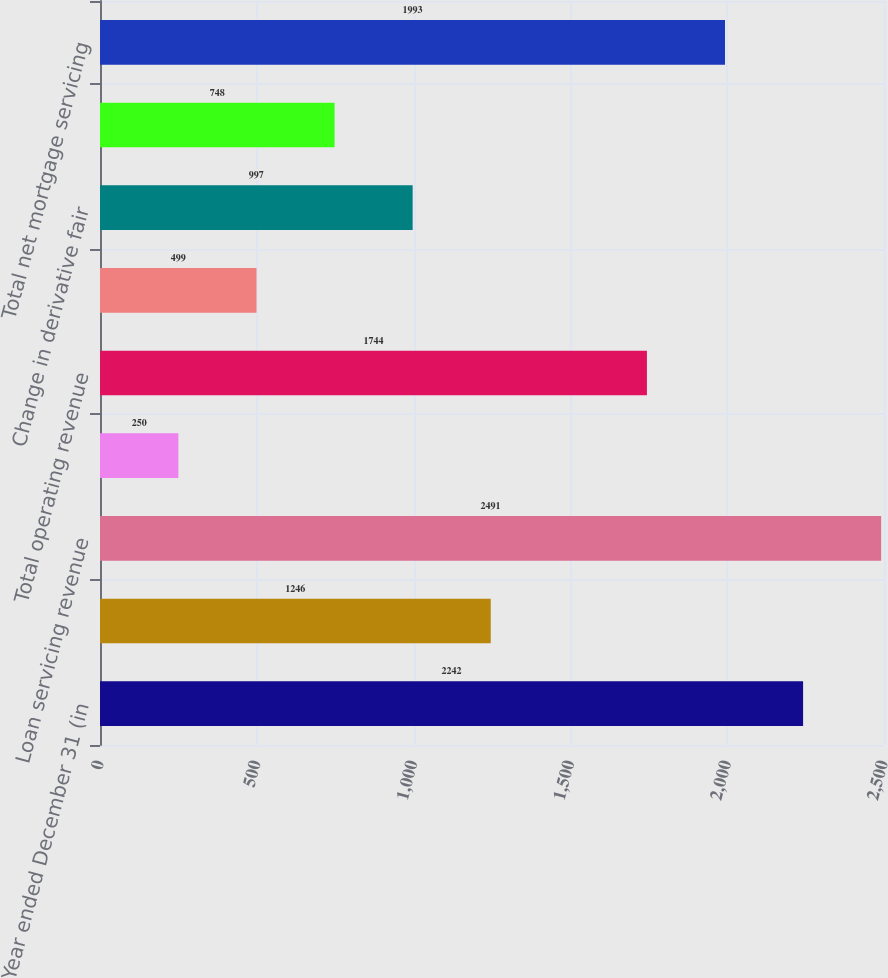<chart> <loc_0><loc_0><loc_500><loc_500><bar_chart><fcel>Year ended December 31 (in<fcel>Net production revenue<fcel>Loan servicing revenue<fcel>Changes in MSR asset fair<fcel>Total operating revenue<fcel>Other changes in MSR asset<fcel>Change in derivative fair<fcel>Total risk management<fcel>Total net mortgage servicing<nl><fcel>2242<fcel>1246<fcel>2491<fcel>250<fcel>1744<fcel>499<fcel>997<fcel>748<fcel>1993<nl></chart> 